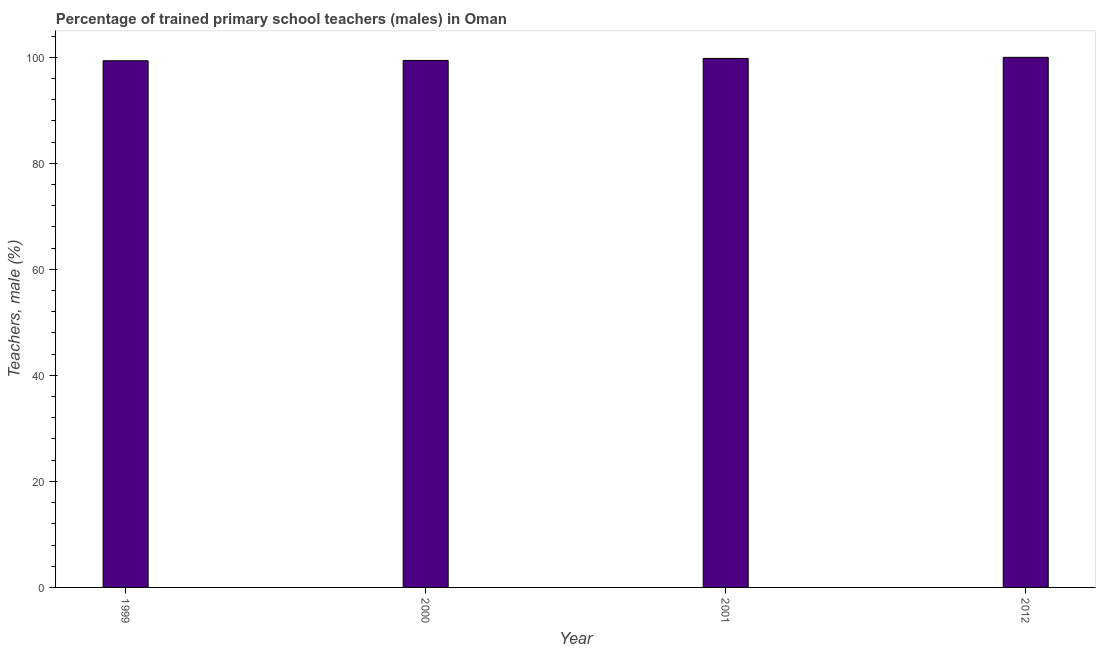What is the title of the graph?
Keep it short and to the point. Percentage of trained primary school teachers (males) in Oman. What is the label or title of the Y-axis?
Offer a terse response. Teachers, male (%). What is the percentage of trained male teachers in 2000?
Your response must be concise. 99.41. Across all years, what is the maximum percentage of trained male teachers?
Provide a short and direct response. 100. Across all years, what is the minimum percentage of trained male teachers?
Provide a short and direct response. 99.35. In which year was the percentage of trained male teachers maximum?
Give a very brief answer. 2012. In which year was the percentage of trained male teachers minimum?
Provide a succinct answer. 1999. What is the sum of the percentage of trained male teachers?
Ensure brevity in your answer.  398.56. What is the difference between the percentage of trained male teachers in 2000 and 2001?
Your response must be concise. -0.38. What is the average percentage of trained male teachers per year?
Offer a very short reply. 99.64. What is the median percentage of trained male teachers?
Offer a terse response. 99.6. What is the ratio of the percentage of trained male teachers in 2001 to that in 2012?
Keep it short and to the point. 1. Is the percentage of trained male teachers in 1999 less than that in 2012?
Your response must be concise. Yes. Is the difference between the percentage of trained male teachers in 2001 and 2012 greater than the difference between any two years?
Ensure brevity in your answer.  No. What is the difference between the highest and the second highest percentage of trained male teachers?
Provide a short and direct response. 0.21. What is the difference between the highest and the lowest percentage of trained male teachers?
Provide a succinct answer. 0.65. How many bars are there?
Your response must be concise. 4. Are all the bars in the graph horizontal?
Give a very brief answer. No. What is the Teachers, male (%) of 1999?
Ensure brevity in your answer.  99.35. What is the Teachers, male (%) in 2000?
Your response must be concise. 99.41. What is the Teachers, male (%) of 2001?
Make the answer very short. 99.79. What is the Teachers, male (%) of 2012?
Offer a terse response. 100. What is the difference between the Teachers, male (%) in 1999 and 2000?
Provide a succinct answer. -0.06. What is the difference between the Teachers, male (%) in 1999 and 2001?
Provide a succinct answer. -0.44. What is the difference between the Teachers, male (%) in 1999 and 2012?
Make the answer very short. -0.65. What is the difference between the Teachers, male (%) in 2000 and 2001?
Your answer should be compact. -0.38. What is the difference between the Teachers, male (%) in 2000 and 2012?
Ensure brevity in your answer.  -0.59. What is the difference between the Teachers, male (%) in 2001 and 2012?
Offer a terse response. -0.21. What is the ratio of the Teachers, male (%) in 1999 to that in 2000?
Keep it short and to the point. 1. What is the ratio of the Teachers, male (%) in 1999 to that in 2012?
Offer a very short reply. 0.99. What is the ratio of the Teachers, male (%) in 2000 to that in 2001?
Ensure brevity in your answer.  1. 